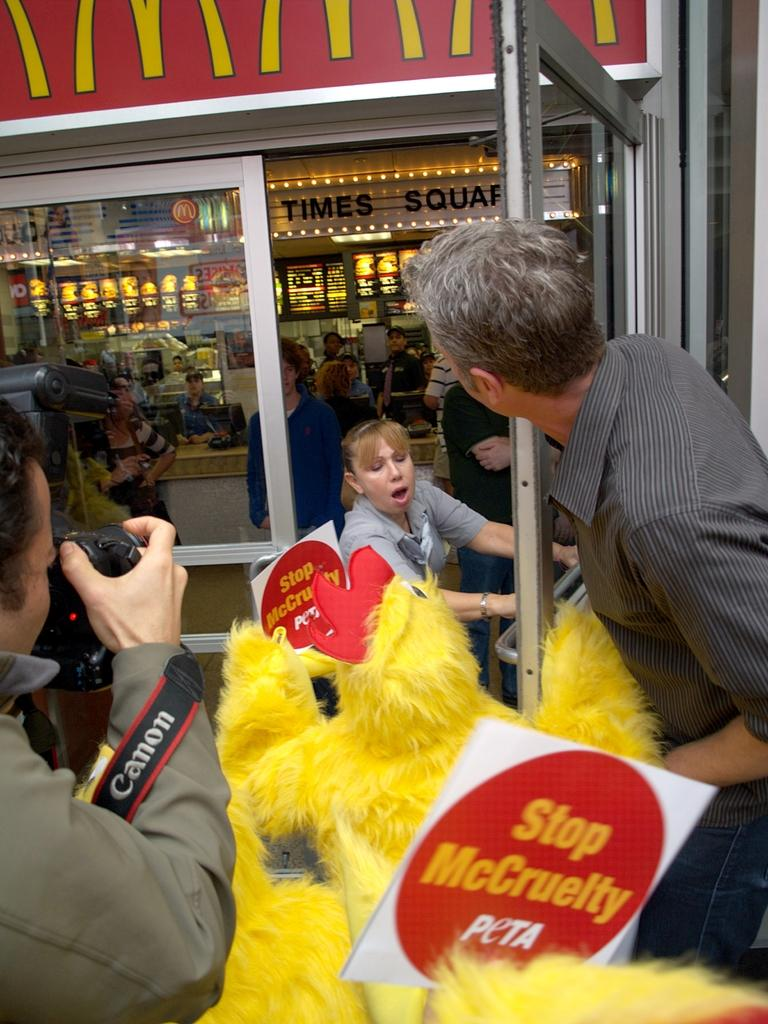What type of establishment is shown in the image? There is a store in the image. Can you describe the people in the image? There are people standing in the image, including a woman opening a door and a man holding a camera. What is the man with the camera doing? The man is taking a picture. What type of page can be seen in the image? There is no page present in the image. What color is the copper in the image? There is no copper present in the image. 